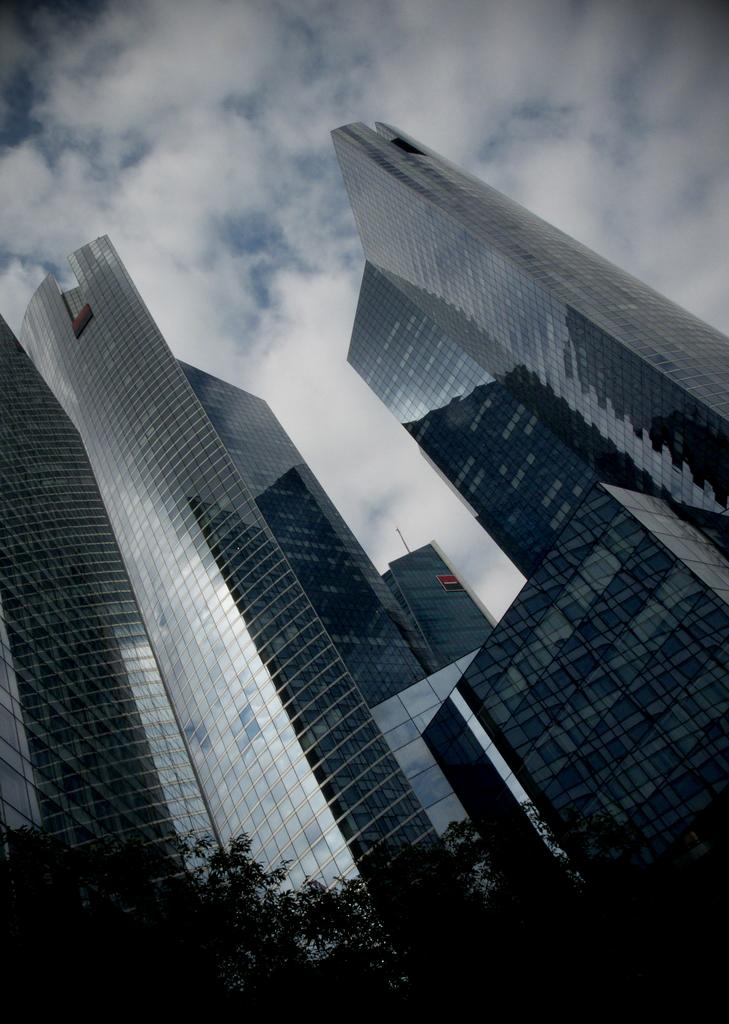What type of structures are visible in the image? There are huge buildings in the image. What can be seen in front of the buildings? There are trees in front of the buildings in the image. How much value does the stranger place on the buildings in the image? There is no stranger present in the image, so it is not possible to determine their opinion or value of the buildings. 